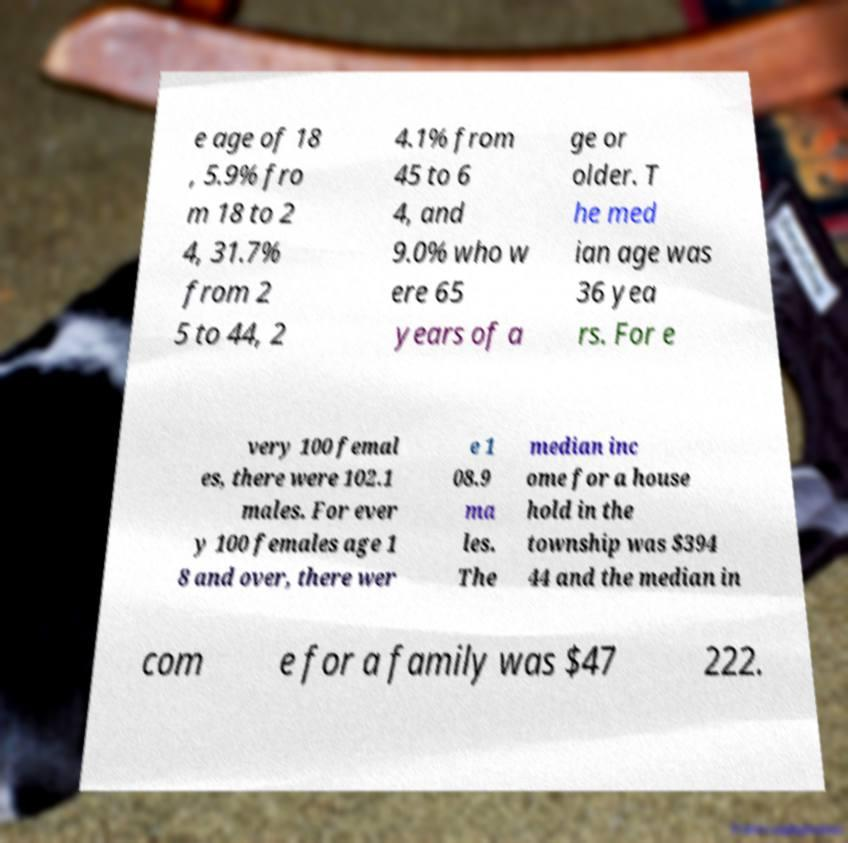Can you read and provide the text displayed in the image?This photo seems to have some interesting text. Can you extract and type it out for me? e age of 18 , 5.9% fro m 18 to 2 4, 31.7% from 2 5 to 44, 2 4.1% from 45 to 6 4, and 9.0% who w ere 65 years of a ge or older. T he med ian age was 36 yea rs. For e very 100 femal es, there were 102.1 males. For ever y 100 females age 1 8 and over, there wer e 1 08.9 ma les. The median inc ome for a house hold in the township was $394 44 and the median in com e for a family was $47 222. 